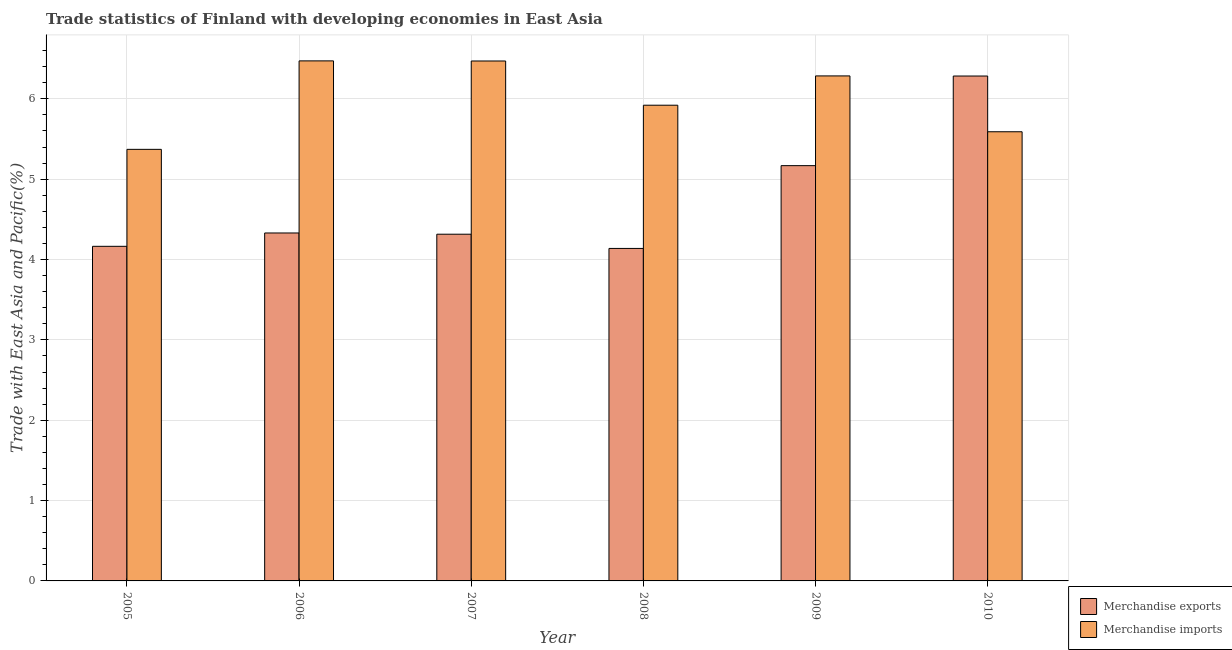Are the number of bars per tick equal to the number of legend labels?
Give a very brief answer. Yes. Are the number of bars on each tick of the X-axis equal?
Offer a terse response. Yes. How many bars are there on the 3rd tick from the left?
Make the answer very short. 2. How many bars are there on the 2nd tick from the right?
Keep it short and to the point. 2. What is the label of the 1st group of bars from the left?
Keep it short and to the point. 2005. What is the merchandise exports in 2007?
Provide a short and direct response. 4.31. Across all years, what is the maximum merchandise exports?
Provide a succinct answer. 6.28. Across all years, what is the minimum merchandise imports?
Offer a very short reply. 5.37. In which year was the merchandise exports maximum?
Your answer should be very brief. 2010. In which year was the merchandise exports minimum?
Make the answer very short. 2008. What is the total merchandise imports in the graph?
Offer a very short reply. 36.11. What is the difference between the merchandise imports in 2005 and that in 2010?
Your answer should be compact. -0.22. What is the difference between the merchandise imports in 2006 and the merchandise exports in 2010?
Give a very brief answer. 0.88. What is the average merchandise imports per year?
Make the answer very short. 6.02. What is the ratio of the merchandise exports in 2006 to that in 2007?
Keep it short and to the point. 1. Is the merchandise exports in 2005 less than that in 2009?
Your answer should be very brief. Yes. What is the difference between the highest and the second highest merchandise imports?
Offer a terse response. 0. What is the difference between the highest and the lowest merchandise imports?
Offer a very short reply. 1.1. In how many years, is the merchandise imports greater than the average merchandise imports taken over all years?
Give a very brief answer. 3. What does the 1st bar from the right in 2005 represents?
Offer a very short reply. Merchandise imports. Are all the bars in the graph horizontal?
Your answer should be compact. No. What is the difference between two consecutive major ticks on the Y-axis?
Ensure brevity in your answer.  1. Does the graph contain any zero values?
Provide a short and direct response. No. Where does the legend appear in the graph?
Your answer should be compact. Bottom right. How many legend labels are there?
Offer a very short reply. 2. How are the legend labels stacked?
Provide a short and direct response. Vertical. What is the title of the graph?
Keep it short and to the point. Trade statistics of Finland with developing economies in East Asia. Does "Technicians" appear as one of the legend labels in the graph?
Your answer should be very brief. No. What is the label or title of the Y-axis?
Offer a very short reply. Trade with East Asia and Pacific(%). What is the Trade with East Asia and Pacific(%) of Merchandise exports in 2005?
Give a very brief answer. 4.16. What is the Trade with East Asia and Pacific(%) in Merchandise imports in 2005?
Provide a short and direct response. 5.37. What is the Trade with East Asia and Pacific(%) of Merchandise exports in 2006?
Keep it short and to the point. 4.33. What is the Trade with East Asia and Pacific(%) of Merchandise imports in 2006?
Offer a terse response. 6.47. What is the Trade with East Asia and Pacific(%) of Merchandise exports in 2007?
Make the answer very short. 4.31. What is the Trade with East Asia and Pacific(%) in Merchandise imports in 2007?
Your response must be concise. 6.47. What is the Trade with East Asia and Pacific(%) in Merchandise exports in 2008?
Make the answer very short. 4.14. What is the Trade with East Asia and Pacific(%) in Merchandise imports in 2008?
Offer a very short reply. 5.92. What is the Trade with East Asia and Pacific(%) in Merchandise exports in 2009?
Offer a terse response. 5.17. What is the Trade with East Asia and Pacific(%) of Merchandise imports in 2009?
Offer a very short reply. 6.28. What is the Trade with East Asia and Pacific(%) in Merchandise exports in 2010?
Your response must be concise. 6.28. What is the Trade with East Asia and Pacific(%) in Merchandise imports in 2010?
Keep it short and to the point. 5.59. Across all years, what is the maximum Trade with East Asia and Pacific(%) in Merchandise exports?
Provide a succinct answer. 6.28. Across all years, what is the maximum Trade with East Asia and Pacific(%) of Merchandise imports?
Your answer should be compact. 6.47. Across all years, what is the minimum Trade with East Asia and Pacific(%) of Merchandise exports?
Provide a short and direct response. 4.14. Across all years, what is the minimum Trade with East Asia and Pacific(%) of Merchandise imports?
Offer a very short reply. 5.37. What is the total Trade with East Asia and Pacific(%) of Merchandise exports in the graph?
Give a very brief answer. 28.4. What is the total Trade with East Asia and Pacific(%) in Merchandise imports in the graph?
Offer a terse response. 36.11. What is the difference between the Trade with East Asia and Pacific(%) of Merchandise exports in 2005 and that in 2006?
Provide a succinct answer. -0.17. What is the difference between the Trade with East Asia and Pacific(%) in Merchandise imports in 2005 and that in 2006?
Your answer should be very brief. -1.1. What is the difference between the Trade with East Asia and Pacific(%) in Merchandise exports in 2005 and that in 2007?
Your response must be concise. -0.15. What is the difference between the Trade with East Asia and Pacific(%) in Merchandise imports in 2005 and that in 2007?
Provide a succinct answer. -1.1. What is the difference between the Trade with East Asia and Pacific(%) of Merchandise exports in 2005 and that in 2008?
Keep it short and to the point. 0.03. What is the difference between the Trade with East Asia and Pacific(%) of Merchandise imports in 2005 and that in 2008?
Your answer should be very brief. -0.55. What is the difference between the Trade with East Asia and Pacific(%) in Merchandise exports in 2005 and that in 2009?
Your answer should be compact. -1. What is the difference between the Trade with East Asia and Pacific(%) of Merchandise imports in 2005 and that in 2009?
Offer a very short reply. -0.91. What is the difference between the Trade with East Asia and Pacific(%) in Merchandise exports in 2005 and that in 2010?
Give a very brief answer. -2.12. What is the difference between the Trade with East Asia and Pacific(%) in Merchandise imports in 2005 and that in 2010?
Offer a very short reply. -0.22. What is the difference between the Trade with East Asia and Pacific(%) of Merchandise exports in 2006 and that in 2007?
Your response must be concise. 0.02. What is the difference between the Trade with East Asia and Pacific(%) of Merchandise imports in 2006 and that in 2007?
Provide a succinct answer. 0. What is the difference between the Trade with East Asia and Pacific(%) in Merchandise exports in 2006 and that in 2008?
Give a very brief answer. 0.19. What is the difference between the Trade with East Asia and Pacific(%) of Merchandise imports in 2006 and that in 2008?
Your response must be concise. 0.55. What is the difference between the Trade with East Asia and Pacific(%) of Merchandise exports in 2006 and that in 2009?
Give a very brief answer. -0.84. What is the difference between the Trade with East Asia and Pacific(%) of Merchandise imports in 2006 and that in 2009?
Offer a terse response. 0.19. What is the difference between the Trade with East Asia and Pacific(%) in Merchandise exports in 2006 and that in 2010?
Your answer should be very brief. -1.95. What is the difference between the Trade with East Asia and Pacific(%) of Merchandise imports in 2006 and that in 2010?
Provide a succinct answer. 0.88. What is the difference between the Trade with East Asia and Pacific(%) in Merchandise exports in 2007 and that in 2008?
Keep it short and to the point. 0.18. What is the difference between the Trade with East Asia and Pacific(%) of Merchandise imports in 2007 and that in 2008?
Your answer should be compact. 0.55. What is the difference between the Trade with East Asia and Pacific(%) in Merchandise exports in 2007 and that in 2009?
Offer a very short reply. -0.85. What is the difference between the Trade with East Asia and Pacific(%) in Merchandise imports in 2007 and that in 2009?
Keep it short and to the point. 0.19. What is the difference between the Trade with East Asia and Pacific(%) in Merchandise exports in 2007 and that in 2010?
Your answer should be compact. -1.97. What is the difference between the Trade with East Asia and Pacific(%) of Merchandise imports in 2007 and that in 2010?
Give a very brief answer. 0.88. What is the difference between the Trade with East Asia and Pacific(%) of Merchandise exports in 2008 and that in 2009?
Keep it short and to the point. -1.03. What is the difference between the Trade with East Asia and Pacific(%) in Merchandise imports in 2008 and that in 2009?
Ensure brevity in your answer.  -0.36. What is the difference between the Trade with East Asia and Pacific(%) in Merchandise exports in 2008 and that in 2010?
Offer a terse response. -2.15. What is the difference between the Trade with East Asia and Pacific(%) in Merchandise imports in 2008 and that in 2010?
Keep it short and to the point. 0.33. What is the difference between the Trade with East Asia and Pacific(%) in Merchandise exports in 2009 and that in 2010?
Provide a succinct answer. -1.12. What is the difference between the Trade with East Asia and Pacific(%) in Merchandise imports in 2009 and that in 2010?
Provide a short and direct response. 0.69. What is the difference between the Trade with East Asia and Pacific(%) in Merchandise exports in 2005 and the Trade with East Asia and Pacific(%) in Merchandise imports in 2006?
Provide a short and direct response. -2.31. What is the difference between the Trade with East Asia and Pacific(%) of Merchandise exports in 2005 and the Trade with East Asia and Pacific(%) of Merchandise imports in 2007?
Provide a succinct answer. -2.31. What is the difference between the Trade with East Asia and Pacific(%) in Merchandise exports in 2005 and the Trade with East Asia and Pacific(%) in Merchandise imports in 2008?
Your answer should be very brief. -1.76. What is the difference between the Trade with East Asia and Pacific(%) of Merchandise exports in 2005 and the Trade with East Asia and Pacific(%) of Merchandise imports in 2009?
Ensure brevity in your answer.  -2.12. What is the difference between the Trade with East Asia and Pacific(%) in Merchandise exports in 2005 and the Trade with East Asia and Pacific(%) in Merchandise imports in 2010?
Ensure brevity in your answer.  -1.43. What is the difference between the Trade with East Asia and Pacific(%) in Merchandise exports in 2006 and the Trade with East Asia and Pacific(%) in Merchandise imports in 2007?
Offer a terse response. -2.14. What is the difference between the Trade with East Asia and Pacific(%) of Merchandise exports in 2006 and the Trade with East Asia and Pacific(%) of Merchandise imports in 2008?
Your response must be concise. -1.59. What is the difference between the Trade with East Asia and Pacific(%) of Merchandise exports in 2006 and the Trade with East Asia and Pacific(%) of Merchandise imports in 2009?
Offer a terse response. -1.95. What is the difference between the Trade with East Asia and Pacific(%) of Merchandise exports in 2006 and the Trade with East Asia and Pacific(%) of Merchandise imports in 2010?
Your response must be concise. -1.26. What is the difference between the Trade with East Asia and Pacific(%) of Merchandise exports in 2007 and the Trade with East Asia and Pacific(%) of Merchandise imports in 2008?
Offer a very short reply. -1.61. What is the difference between the Trade with East Asia and Pacific(%) in Merchandise exports in 2007 and the Trade with East Asia and Pacific(%) in Merchandise imports in 2009?
Your answer should be very brief. -1.97. What is the difference between the Trade with East Asia and Pacific(%) of Merchandise exports in 2007 and the Trade with East Asia and Pacific(%) of Merchandise imports in 2010?
Offer a terse response. -1.28. What is the difference between the Trade with East Asia and Pacific(%) of Merchandise exports in 2008 and the Trade with East Asia and Pacific(%) of Merchandise imports in 2009?
Make the answer very short. -2.15. What is the difference between the Trade with East Asia and Pacific(%) in Merchandise exports in 2008 and the Trade with East Asia and Pacific(%) in Merchandise imports in 2010?
Give a very brief answer. -1.45. What is the difference between the Trade with East Asia and Pacific(%) of Merchandise exports in 2009 and the Trade with East Asia and Pacific(%) of Merchandise imports in 2010?
Your response must be concise. -0.42. What is the average Trade with East Asia and Pacific(%) of Merchandise exports per year?
Your answer should be compact. 4.73. What is the average Trade with East Asia and Pacific(%) of Merchandise imports per year?
Provide a short and direct response. 6.02. In the year 2005, what is the difference between the Trade with East Asia and Pacific(%) in Merchandise exports and Trade with East Asia and Pacific(%) in Merchandise imports?
Your answer should be very brief. -1.21. In the year 2006, what is the difference between the Trade with East Asia and Pacific(%) of Merchandise exports and Trade with East Asia and Pacific(%) of Merchandise imports?
Ensure brevity in your answer.  -2.14. In the year 2007, what is the difference between the Trade with East Asia and Pacific(%) in Merchandise exports and Trade with East Asia and Pacific(%) in Merchandise imports?
Make the answer very short. -2.16. In the year 2008, what is the difference between the Trade with East Asia and Pacific(%) of Merchandise exports and Trade with East Asia and Pacific(%) of Merchandise imports?
Make the answer very short. -1.78. In the year 2009, what is the difference between the Trade with East Asia and Pacific(%) of Merchandise exports and Trade with East Asia and Pacific(%) of Merchandise imports?
Provide a short and direct response. -1.12. In the year 2010, what is the difference between the Trade with East Asia and Pacific(%) of Merchandise exports and Trade with East Asia and Pacific(%) of Merchandise imports?
Offer a terse response. 0.69. What is the ratio of the Trade with East Asia and Pacific(%) in Merchandise exports in 2005 to that in 2006?
Give a very brief answer. 0.96. What is the ratio of the Trade with East Asia and Pacific(%) of Merchandise imports in 2005 to that in 2006?
Your response must be concise. 0.83. What is the ratio of the Trade with East Asia and Pacific(%) in Merchandise exports in 2005 to that in 2007?
Provide a short and direct response. 0.97. What is the ratio of the Trade with East Asia and Pacific(%) of Merchandise imports in 2005 to that in 2007?
Keep it short and to the point. 0.83. What is the ratio of the Trade with East Asia and Pacific(%) in Merchandise exports in 2005 to that in 2008?
Give a very brief answer. 1.01. What is the ratio of the Trade with East Asia and Pacific(%) in Merchandise imports in 2005 to that in 2008?
Provide a short and direct response. 0.91. What is the ratio of the Trade with East Asia and Pacific(%) in Merchandise exports in 2005 to that in 2009?
Give a very brief answer. 0.81. What is the ratio of the Trade with East Asia and Pacific(%) in Merchandise imports in 2005 to that in 2009?
Offer a very short reply. 0.85. What is the ratio of the Trade with East Asia and Pacific(%) in Merchandise exports in 2005 to that in 2010?
Provide a short and direct response. 0.66. What is the ratio of the Trade with East Asia and Pacific(%) in Merchandise imports in 2005 to that in 2010?
Offer a terse response. 0.96. What is the ratio of the Trade with East Asia and Pacific(%) in Merchandise exports in 2006 to that in 2007?
Make the answer very short. 1. What is the ratio of the Trade with East Asia and Pacific(%) in Merchandise exports in 2006 to that in 2008?
Offer a very short reply. 1.05. What is the ratio of the Trade with East Asia and Pacific(%) in Merchandise imports in 2006 to that in 2008?
Your answer should be compact. 1.09. What is the ratio of the Trade with East Asia and Pacific(%) of Merchandise exports in 2006 to that in 2009?
Ensure brevity in your answer.  0.84. What is the ratio of the Trade with East Asia and Pacific(%) in Merchandise imports in 2006 to that in 2009?
Make the answer very short. 1.03. What is the ratio of the Trade with East Asia and Pacific(%) of Merchandise exports in 2006 to that in 2010?
Your answer should be very brief. 0.69. What is the ratio of the Trade with East Asia and Pacific(%) in Merchandise imports in 2006 to that in 2010?
Your response must be concise. 1.16. What is the ratio of the Trade with East Asia and Pacific(%) of Merchandise exports in 2007 to that in 2008?
Your answer should be compact. 1.04. What is the ratio of the Trade with East Asia and Pacific(%) of Merchandise imports in 2007 to that in 2008?
Give a very brief answer. 1.09. What is the ratio of the Trade with East Asia and Pacific(%) of Merchandise exports in 2007 to that in 2009?
Offer a very short reply. 0.83. What is the ratio of the Trade with East Asia and Pacific(%) of Merchandise imports in 2007 to that in 2009?
Your response must be concise. 1.03. What is the ratio of the Trade with East Asia and Pacific(%) in Merchandise exports in 2007 to that in 2010?
Ensure brevity in your answer.  0.69. What is the ratio of the Trade with East Asia and Pacific(%) in Merchandise imports in 2007 to that in 2010?
Offer a very short reply. 1.16. What is the ratio of the Trade with East Asia and Pacific(%) of Merchandise exports in 2008 to that in 2009?
Provide a short and direct response. 0.8. What is the ratio of the Trade with East Asia and Pacific(%) of Merchandise imports in 2008 to that in 2009?
Keep it short and to the point. 0.94. What is the ratio of the Trade with East Asia and Pacific(%) in Merchandise exports in 2008 to that in 2010?
Your answer should be very brief. 0.66. What is the ratio of the Trade with East Asia and Pacific(%) in Merchandise imports in 2008 to that in 2010?
Offer a very short reply. 1.06. What is the ratio of the Trade with East Asia and Pacific(%) of Merchandise exports in 2009 to that in 2010?
Your answer should be very brief. 0.82. What is the ratio of the Trade with East Asia and Pacific(%) of Merchandise imports in 2009 to that in 2010?
Offer a terse response. 1.12. What is the difference between the highest and the second highest Trade with East Asia and Pacific(%) of Merchandise exports?
Offer a terse response. 1.12. What is the difference between the highest and the second highest Trade with East Asia and Pacific(%) of Merchandise imports?
Provide a succinct answer. 0. What is the difference between the highest and the lowest Trade with East Asia and Pacific(%) in Merchandise exports?
Make the answer very short. 2.15. What is the difference between the highest and the lowest Trade with East Asia and Pacific(%) in Merchandise imports?
Keep it short and to the point. 1.1. 